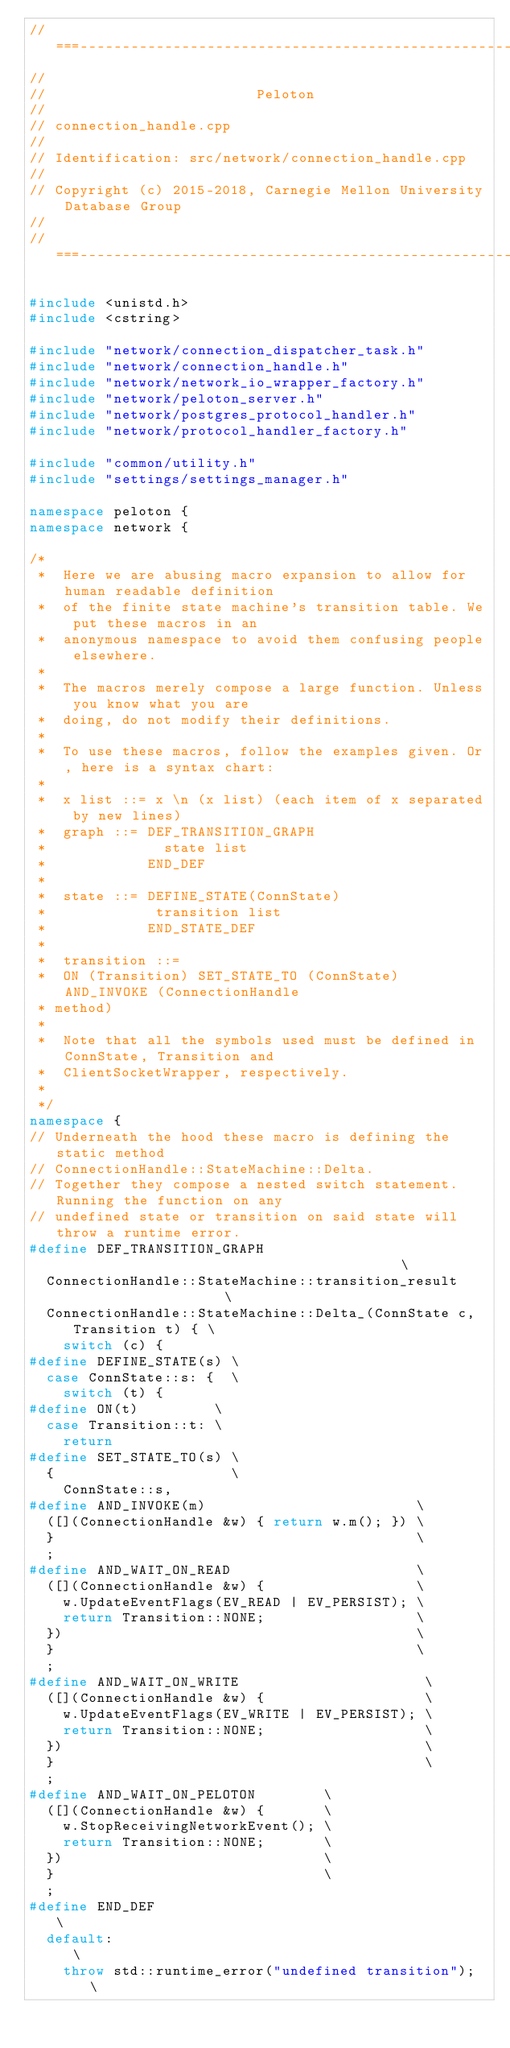<code> <loc_0><loc_0><loc_500><loc_500><_C++_>//===----------------------------------------------------------------------===//
//
//                         Peloton
//
// connection_handle.cpp
//
// Identification: src/network/connection_handle.cpp
//
// Copyright (c) 2015-2018, Carnegie Mellon University Database Group
//
//===----------------------------------------------------------------------===//

#include <unistd.h>
#include <cstring>

#include "network/connection_dispatcher_task.h"
#include "network/connection_handle.h"
#include "network/network_io_wrapper_factory.h"
#include "network/peloton_server.h"
#include "network/postgres_protocol_handler.h"
#include "network/protocol_handler_factory.h"

#include "common/utility.h"
#include "settings/settings_manager.h"

namespace peloton {
namespace network {

/*
 *  Here we are abusing macro expansion to allow for human readable definition
 *  of the finite state machine's transition table. We put these macros in an
 *  anonymous namespace to avoid them confusing people elsewhere.
 *
 *  The macros merely compose a large function. Unless you know what you are
 *  doing, do not modify their definitions.
 *
 *  To use these macros, follow the examples given. Or, here is a syntax chart:
 *
 *  x list ::= x \n (x list) (each item of x separated by new lines)
 *  graph ::= DEF_TRANSITION_GRAPH
 *              state list
 *            END_DEF
 *
 *  state ::= DEFINE_STATE(ConnState)
 *             transition list
 *            END_STATE_DEF
 *
 *  transition ::=
 *  ON (Transition) SET_STATE_TO (ConnState) AND_INVOKE (ConnectionHandle
 * method)
 *
 *  Note that all the symbols used must be defined in ConnState, Transition and
 *  ClientSocketWrapper, respectively.
 *
 */
namespace {
// Underneath the hood these macro is defining the static method
// ConnectionHandle::StateMachine::Delta.
// Together they compose a nested switch statement. Running the function on any
// undefined state or transition on said state will throw a runtime error.
#define DEF_TRANSITION_GRAPH                                          \
  ConnectionHandle::StateMachine::transition_result                   \
  ConnectionHandle::StateMachine::Delta_(ConnState c, Transition t) { \
    switch (c) {
#define DEFINE_STATE(s) \
  case ConnState::s: {  \
    switch (t) {
#define ON(t)         \
  case Transition::t: \
    return
#define SET_STATE_TO(s) \
  {                     \
    ConnState::s,
#define AND_INVOKE(m)                         \
  ([](ConnectionHandle &w) { return w.m(); }) \
  }                                           \
  ;
#define AND_WAIT_ON_READ                      \
  ([](ConnectionHandle &w) {                  \
    w.UpdateEventFlags(EV_READ | EV_PERSIST); \
    return Transition::NONE;                  \
  })                                          \
  }                                           \
  ;
#define AND_WAIT_ON_WRITE                      \
  ([](ConnectionHandle &w) {                   \
    w.UpdateEventFlags(EV_WRITE | EV_PERSIST); \
    return Transition::NONE;                   \
  })                                           \
  }                                            \
  ;
#define AND_WAIT_ON_PELOTON        \
  ([](ConnectionHandle &w) {       \
    w.StopReceivingNetworkEvent(); \
    return Transition::NONE;       \
  })                               \
  }                                \
  ;
#define END_DEF                                       \
  default:                                            \
    throw std::runtime_error("undefined transition"); \</code> 